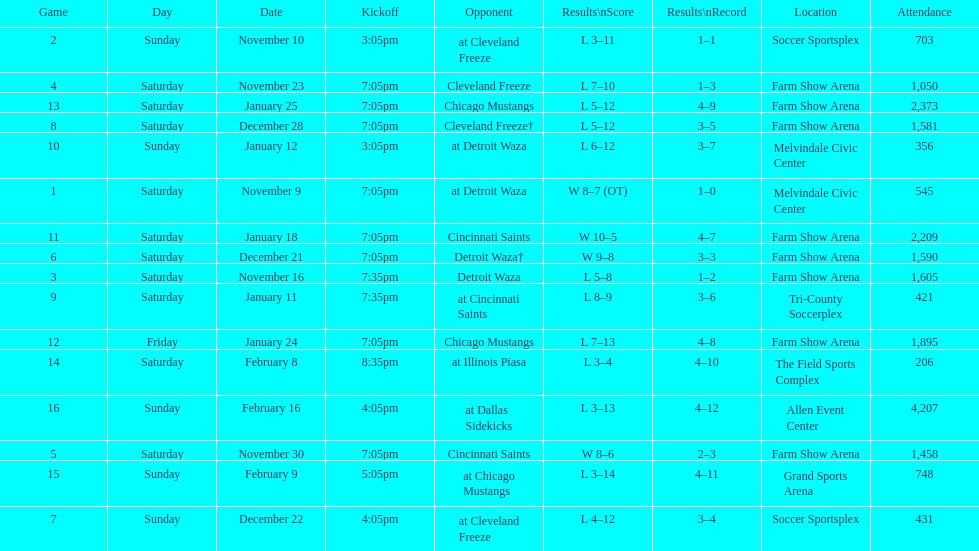How many times did the team play at home but did not win? 5. 